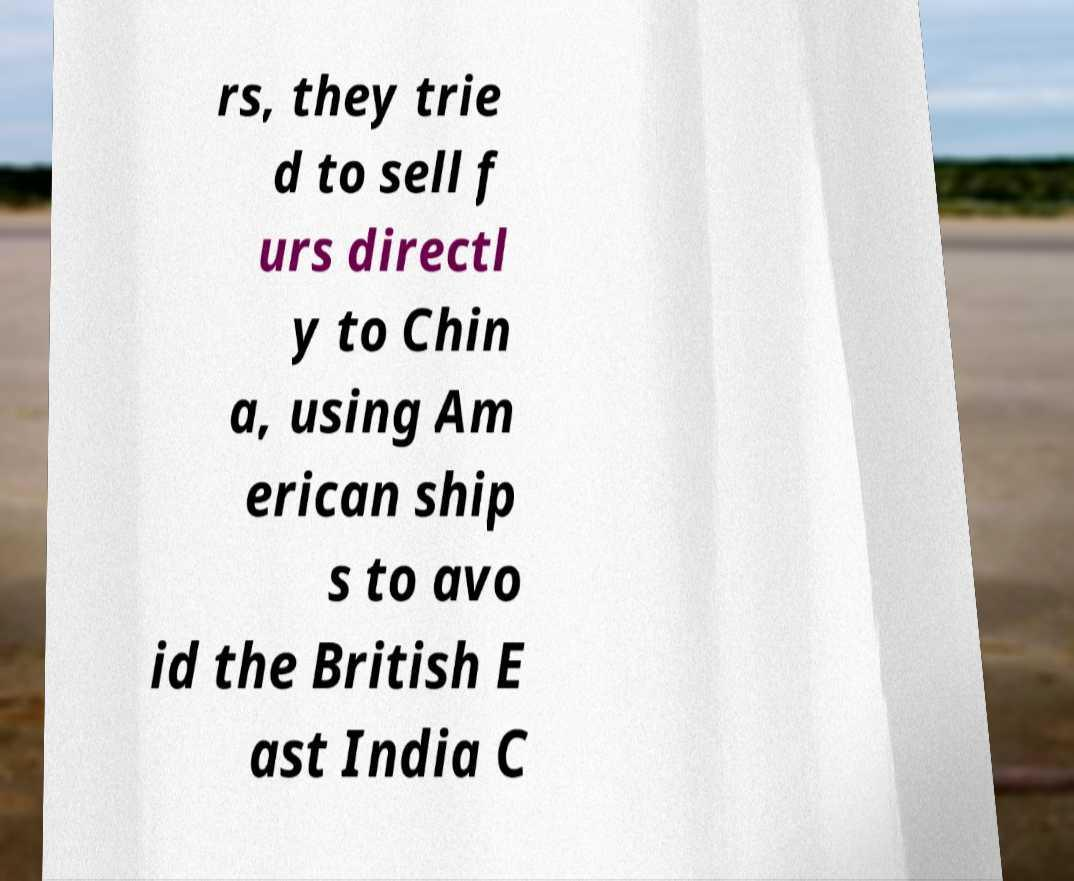What messages or text are displayed in this image? I need them in a readable, typed format. rs, they trie d to sell f urs directl y to Chin a, using Am erican ship s to avo id the British E ast India C 